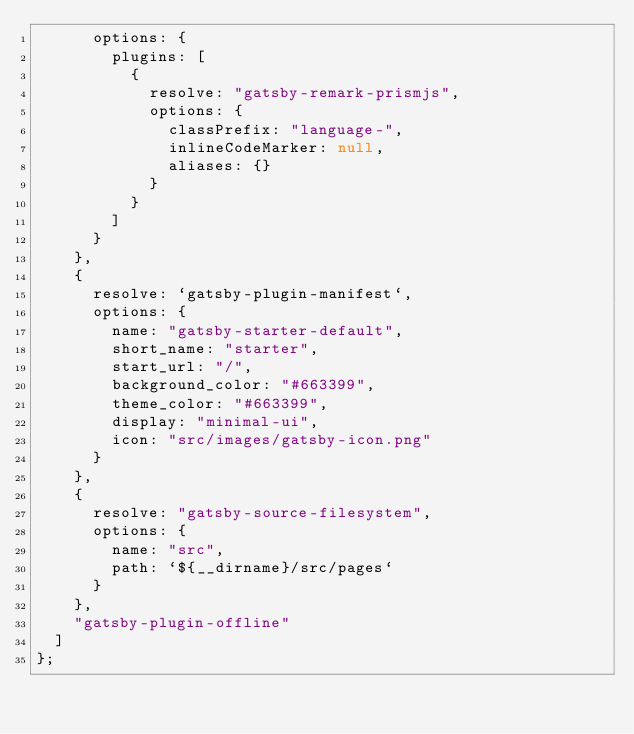Convert code to text. <code><loc_0><loc_0><loc_500><loc_500><_JavaScript_>      options: {
        plugins: [
          {
            resolve: "gatsby-remark-prismjs",
            options: {
              classPrefix: "language-",
              inlineCodeMarker: null,
              aliases: {}
            }
          }
        ]
      }
    },
    {
      resolve: `gatsby-plugin-manifest`,
      options: {
        name: "gatsby-starter-default",
        short_name: "starter",
        start_url: "/",
        background_color: "#663399",
        theme_color: "#663399",
        display: "minimal-ui",
        icon: "src/images/gatsby-icon.png"
      }
    },
    {
      resolve: "gatsby-source-filesystem",
      options: {
        name: "src",
        path: `${__dirname}/src/pages`
      }
    },
    "gatsby-plugin-offline"
  ]
};
</code> 